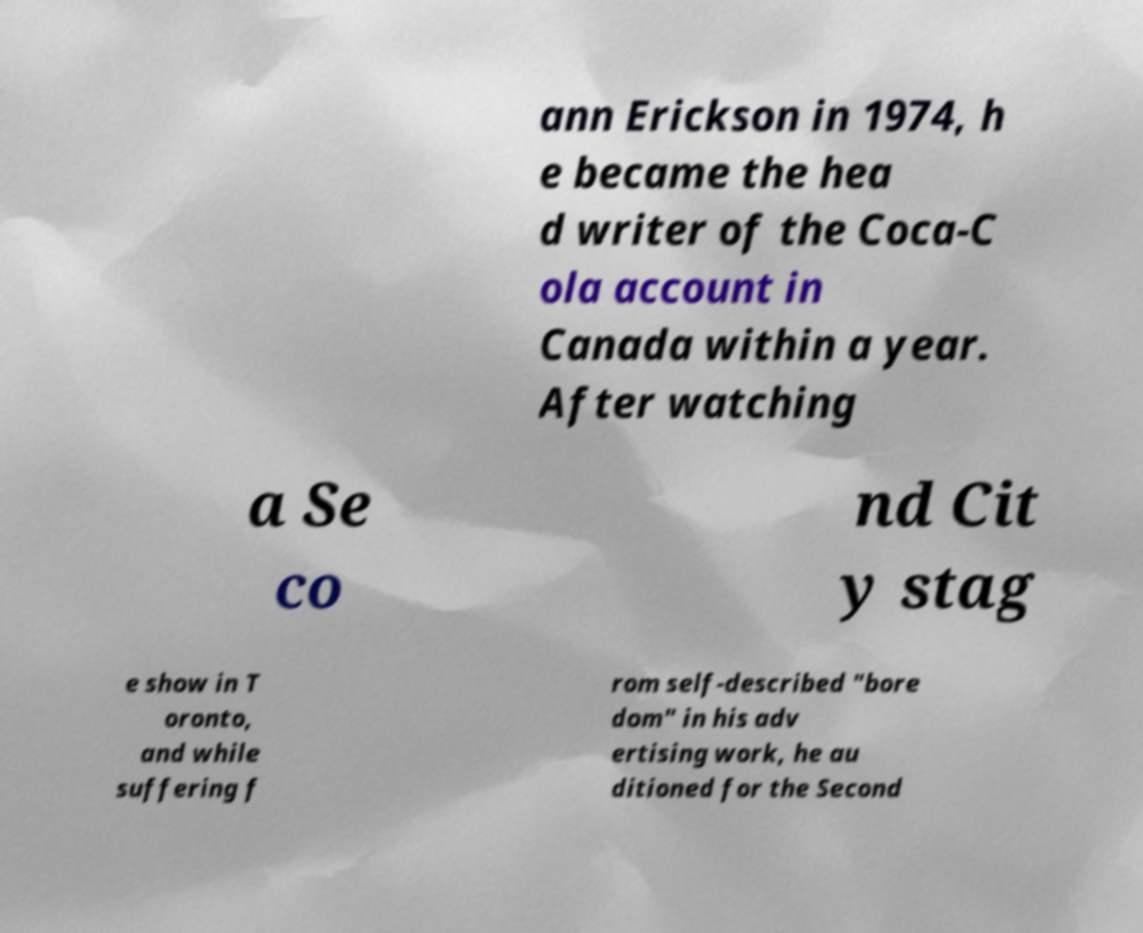There's text embedded in this image that I need extracted. Can you transcribe it verbatim? ann Erickson in 1974, h e became the hea d writer of the Coca-C ola account in Canada within a year. After watching a Se co nd Cit y stag e show in T oronto, and while suffering f rom self-described "bore dom" in his adv ertising work, he au ditioned for the Second 